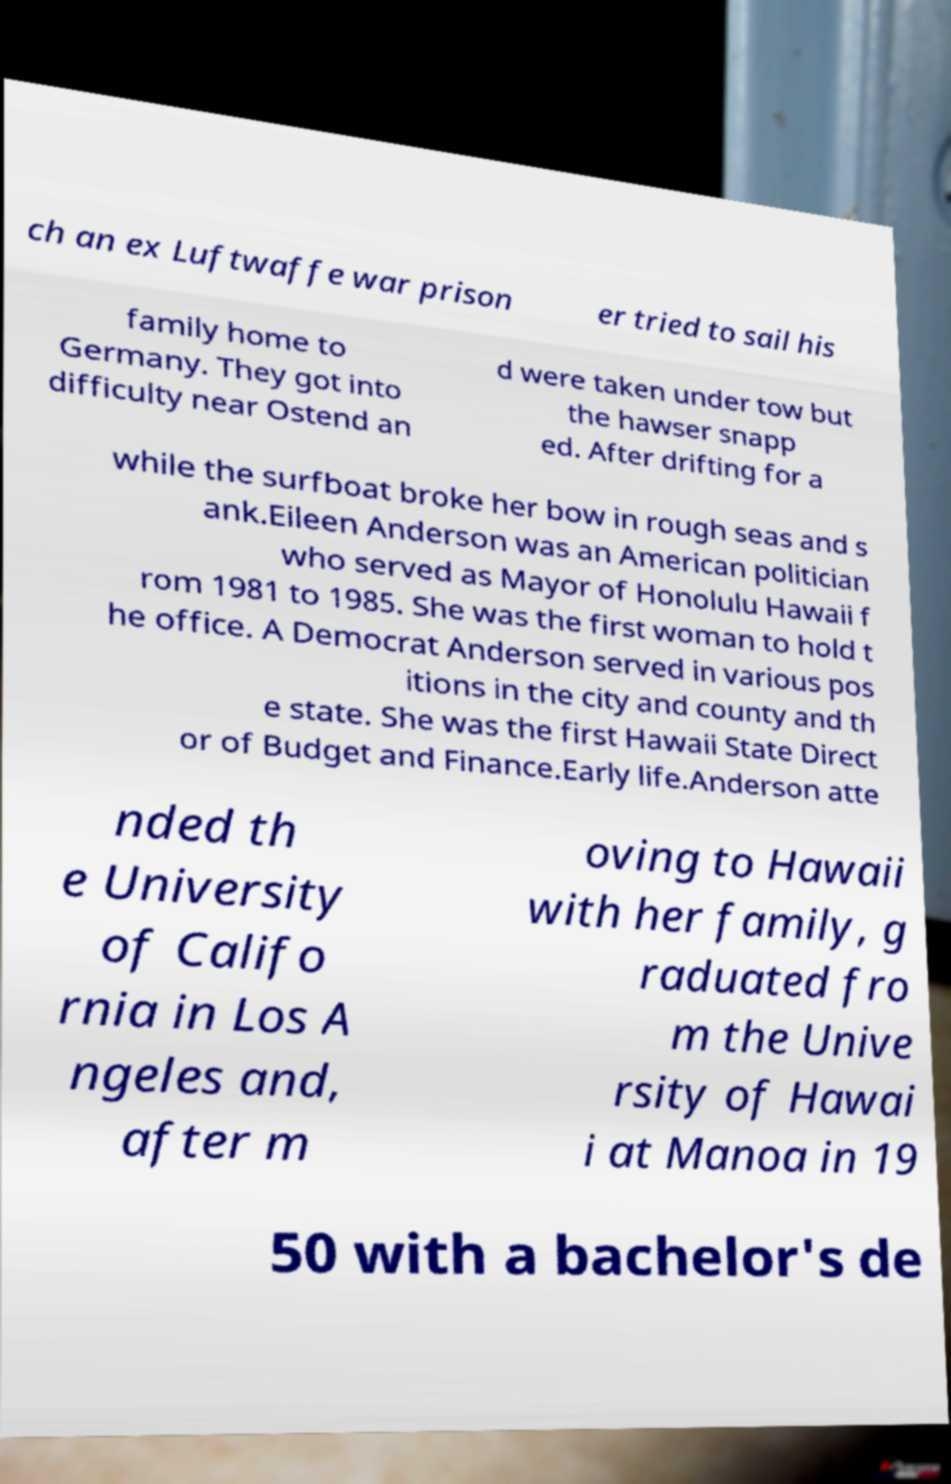There's text embedded in this image that I need extracted. Can you transcribe it verbatim? ch an ex Luftwaffe war prison er tried to sail his family home to Germany. They got into difficulty near Ostend an d were taken under tow but the hawser snapp ed. After drifting for a while the surfboat broke her bow in rough seas and s ank.Eileen Anderson was an American politician who served as Mayor of Honolulu Hawaii f rom 1981 to 1985. She was the first woman to hold t he office. A Democrat Anderson served in various pos itions in the city and county and th e state. She was the first Hawaii State Direct or of Budget and Finance.Early life.Anderson atte nded th e University of Califo rnia in Los A ngeles and, after m oving to Hawaii with her family, g raduated fro m the Unive rsity of Hawai i at Manoa in 19 50 with a bachelor's de 